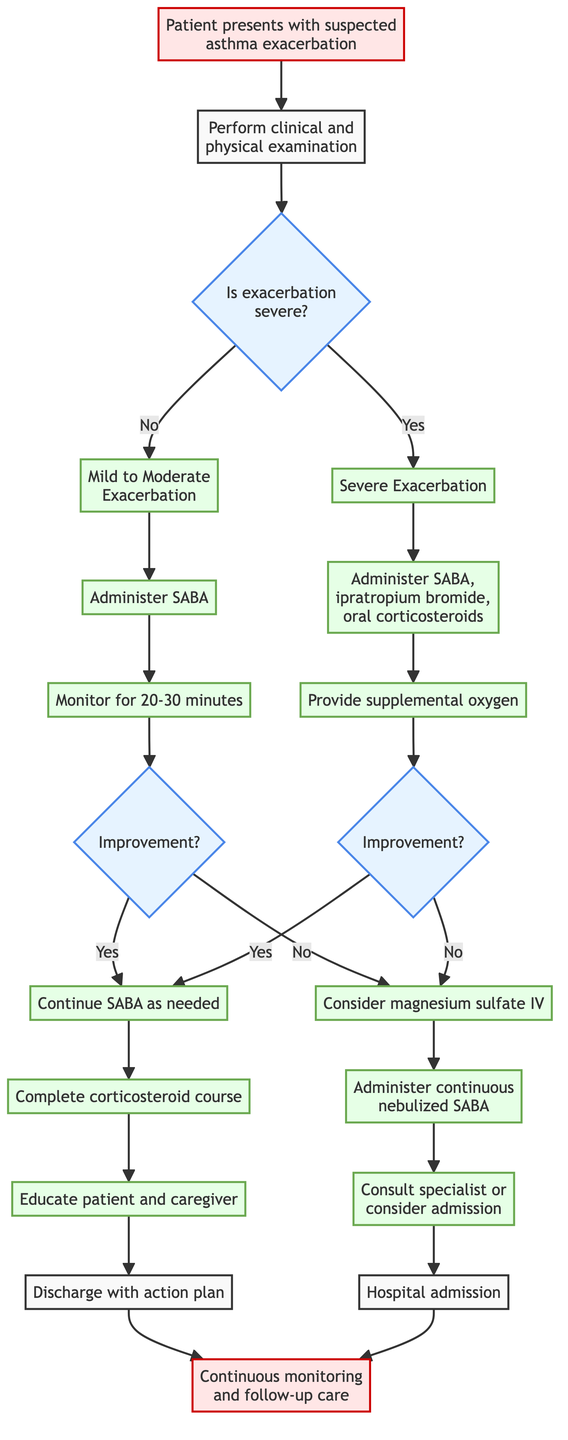What is the first step after the patient presents with suspected asthma exacerbation? The diagram indicates that the first step is to perform a clinical and physical examination after the patient presents. This step is connected directly to the starting point of the pathway.
Answer: Perform clinical and physical examination How many treatments are indicated for a mild to moderate exacerbation? The diagram shows that there are two specific treatments: administer SABA and monitor response to treatment. Therefore, there are two treatments in total for this severity of exacerbation.
Answer: 2 What should be provided along with oral corticosteroids in a severe exacerbation? In the diagram, it specifies that oral corticosteroids should be given along with SABA and ipratropium bromide during a severe exacerbation, indicating a combination of three treatments.
Answer: SABA and ipratropium bromide What is the next step if the patient shows improvement after treatment? According to the diagram, if the patient shows improvement, the next step is to continue SABA treatment every four hours as needed, which leads to further education and discharge.
Answer: Continue SABA treatment every 4 hours as needed If the exacerbation is severe, what is the immediate action? The diagram clearly lists immediate actions for a severe exacerbation, which includes administering SABA and ipratropium bromide along with giving oral corticosteroids.
Answer: Administer SABA and ipratropium bromide What action should be taken if there is no improvement after treating a severe exacerbation? The pathway indicates that if there is no improvement, the further actions should include considering magnesium sulfate IV and administering continuous nebulized SABA.
Answer: Consider magnesium sulfate IV How many decision points are present in the pathway? By examining the diagram, there are three decision points: one after assessing severity, one after monitoring for improvement in a mild-moderate exacerbation, and one after monitoring for improvement in a severe exacerbation. Thus, there are three decision points total.
Answer: 3 What follows a hospital admission for further management? The diagram shows that after hospital admission for further management, the next steps lead to continuous monitoring and follow-up care, indicating ongoing care and assessment.
Answer: Continuous monitoring and follow-up care 